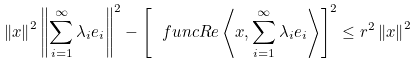<formula> <loc_0><loc_0><loc_500><loc_500>\left \| x \right \| ^ { 2 } \left \| \sum _ { i = 1 } ^ { \infty } \lambda _ { i } e _ { i } \right \| ^ { 2 } - \left [ \ f u n c { R e } \left \langle x , \sum _ { i = 1 } ^ { \infty } \lambda _ { i } e _ { i } \right \rangle \right ] ^ { 2 } \leq r ^ { 2 } \left \| x \right \| ^ { 2 }</formula> 